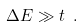Convert formula to latex. <formula><loc_0><loc_0><loc_500><loc_500>\Delta E \gg t \ .</formula> 